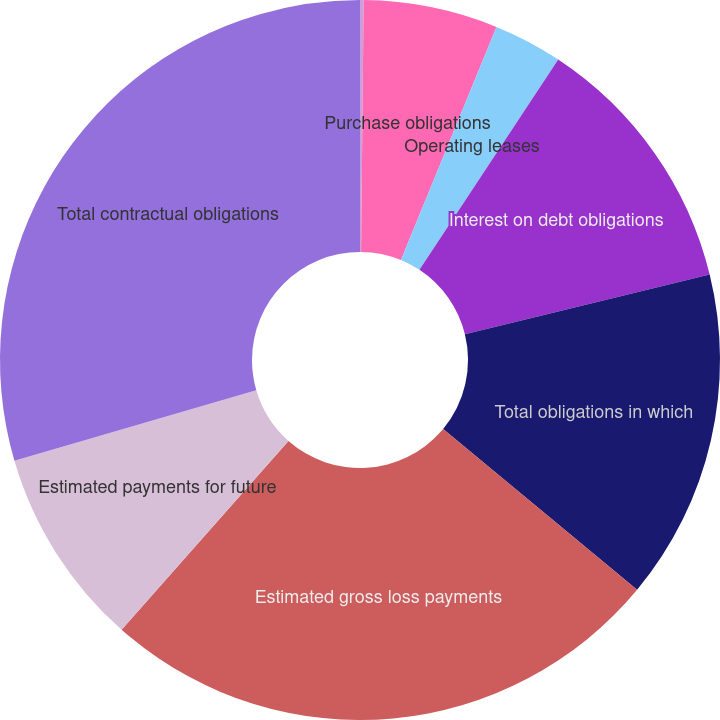<chart> <loc_0><loc_0><loc_500><loc_500><pie_chart><fcel>Deposit liabilities<fcel>Purchase obligations<fcel>Operating leases<fcel>Interest on debt obligations<fcel>Total obligations in which<fcel>Estimated gross loss payments<fcel>Estimated payments for future<fcel>Total contractual obligations<nl><fcel>0.16%<fcel>6.03%<fcel>3.09%<fcel>11.9%<fcel>14.84%<fcel>25.5%<fcel>8.96%<fcel>29.52%<nl></chart> 